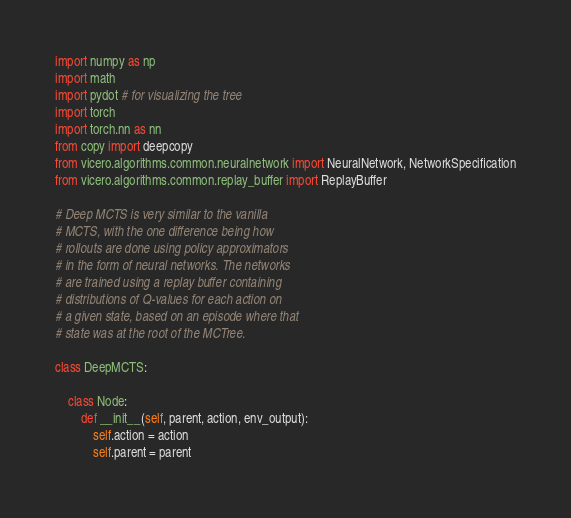<code> <loc_0><loc_0><loc_500><loc_500><_Python_>import numpy as np
import math
import pydot # for visualizing the tree
import torch
import torch.nn as nn
from copy import deepcopy
from vicero.algorithms.common.neuralnetwork import NeuralNetwork, NetworkSpecification
from vicero.algorithms.common.replay_buffer import ReplayBuffer

# Deep MCTS is very similar to the vanilla
# MCTS, with the one difference being how
# rollouts are done using policy approximators
# in the form of neural networks. The networks
# are trained using a replay buffer containing
# distributions of Q-values for each action on
# a given state, based on an episode where that
# state was at the root of the MCTree.

class DeepMCTS:

    class Node:
        def __init__(self, parent, action, env_output):
            self.action = action
            self.parent = parent</code> 